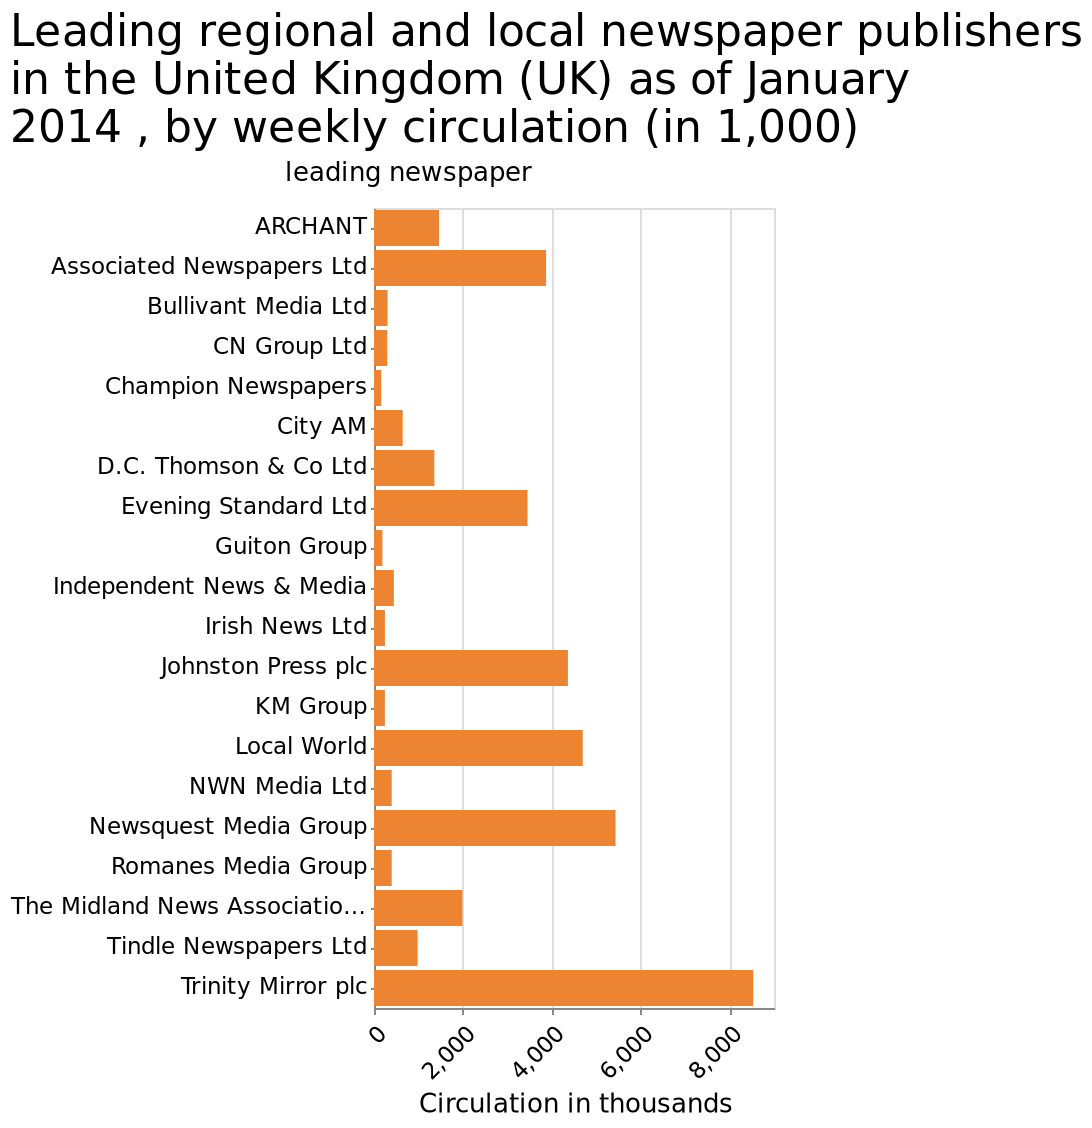<image>
Offer a thorough analysis of the image. Trinity mirror is the post popular publisher in the UK with over 2000 more copies in circulation than its closest competitor newsquest media group. What is the range of circulation shown on the x-axis of the bar graph?  The range of circulation is from 0 to 8,000 in thousands. Which newspaper publisher has the highest weekly circulation in the United Kingdom as of January 2014?  Trinity Mirror plc How many more copies does Trinity Mirror have in circulation compared to Newsquest Media Group? Trinity Mirror has over 2000 more copies in circulation than Newsquest Media Group. Which publisher has the highest circulation in the UK? Trinity Mirror has the highest circulation among publishers in the UK. Describe the following image in detail Leading regional and local newspaper publishers in the United Kingdom (UK) as of January 2014 , by weekly circulation (in 1,000) is a bar graph. The y-axis measures leading newspaper along categorical scale from ARCHANT to Trinity Mirror plc while the x-axis shows Circulation in thousands along linear scale of range 0 to 8,000. 